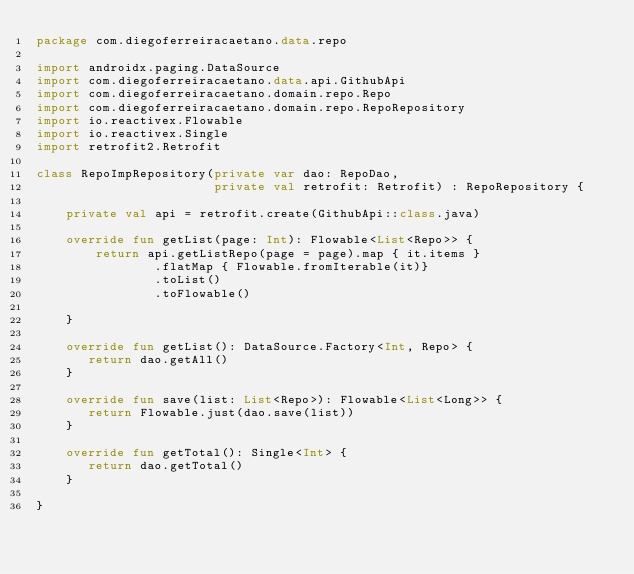<code> <loc_0><loc_0><loc_500><loc_500><_Kotlin_>package com.diegoferreiracaetano.data.repo

import androidx.paging.DataSource
import com.diegoferreiracaetano.data.api.GithubApi
import com.diegoferreiracaetano.domain.repo.Repo
import com.diegoferreiracaetano.domain.repo.RepoRepository
import io.reactivex.Flowable
import io.reactivex.Single
import retrofit2.Retrofit

class RepoImpRepository(private var dao: RepoDao,
                        private val retrofit: Retrofit) : RepoRepository {

    private val api = retrofit.create(GithubApi::class.java)

    override fun getList(page: Int): Flowable<List<Repo>> {
        return api.getListRepo(page = page).map { it.items }
                .flatMap { Flowable.fromIterable(it)}
                .toList()
                .toFlowable()

    }

    override fun getList(): DataSource.Factory<Int, Repo> {
       return dao.getAll()
    }

    override fun save(list: List<Repo>): Flowable<List<Long>> {
       return Flowable.just(dao.save(list))
    }

    override fun getTotal(): Single<Int> {
       return dao.getTotal()
    }

}
</code> 